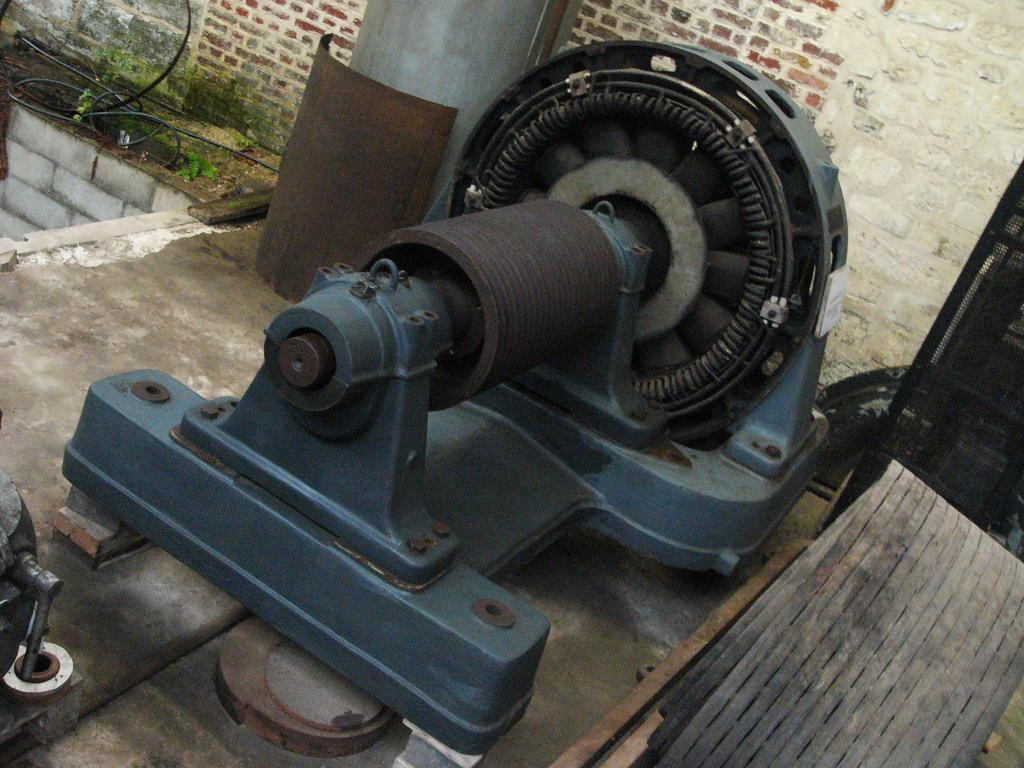What is the main object in the image? There is a rotor in the image. What type of terrain can be seen in the image? The land is visible in the image. What else is present in the image besides the rotor? There are wires in the image. What type of structure is visible in the image? There is a brick wall in the image. What type of music is being played by the rotor in the image? There is no music or sound being produced by the rotor in the image. 